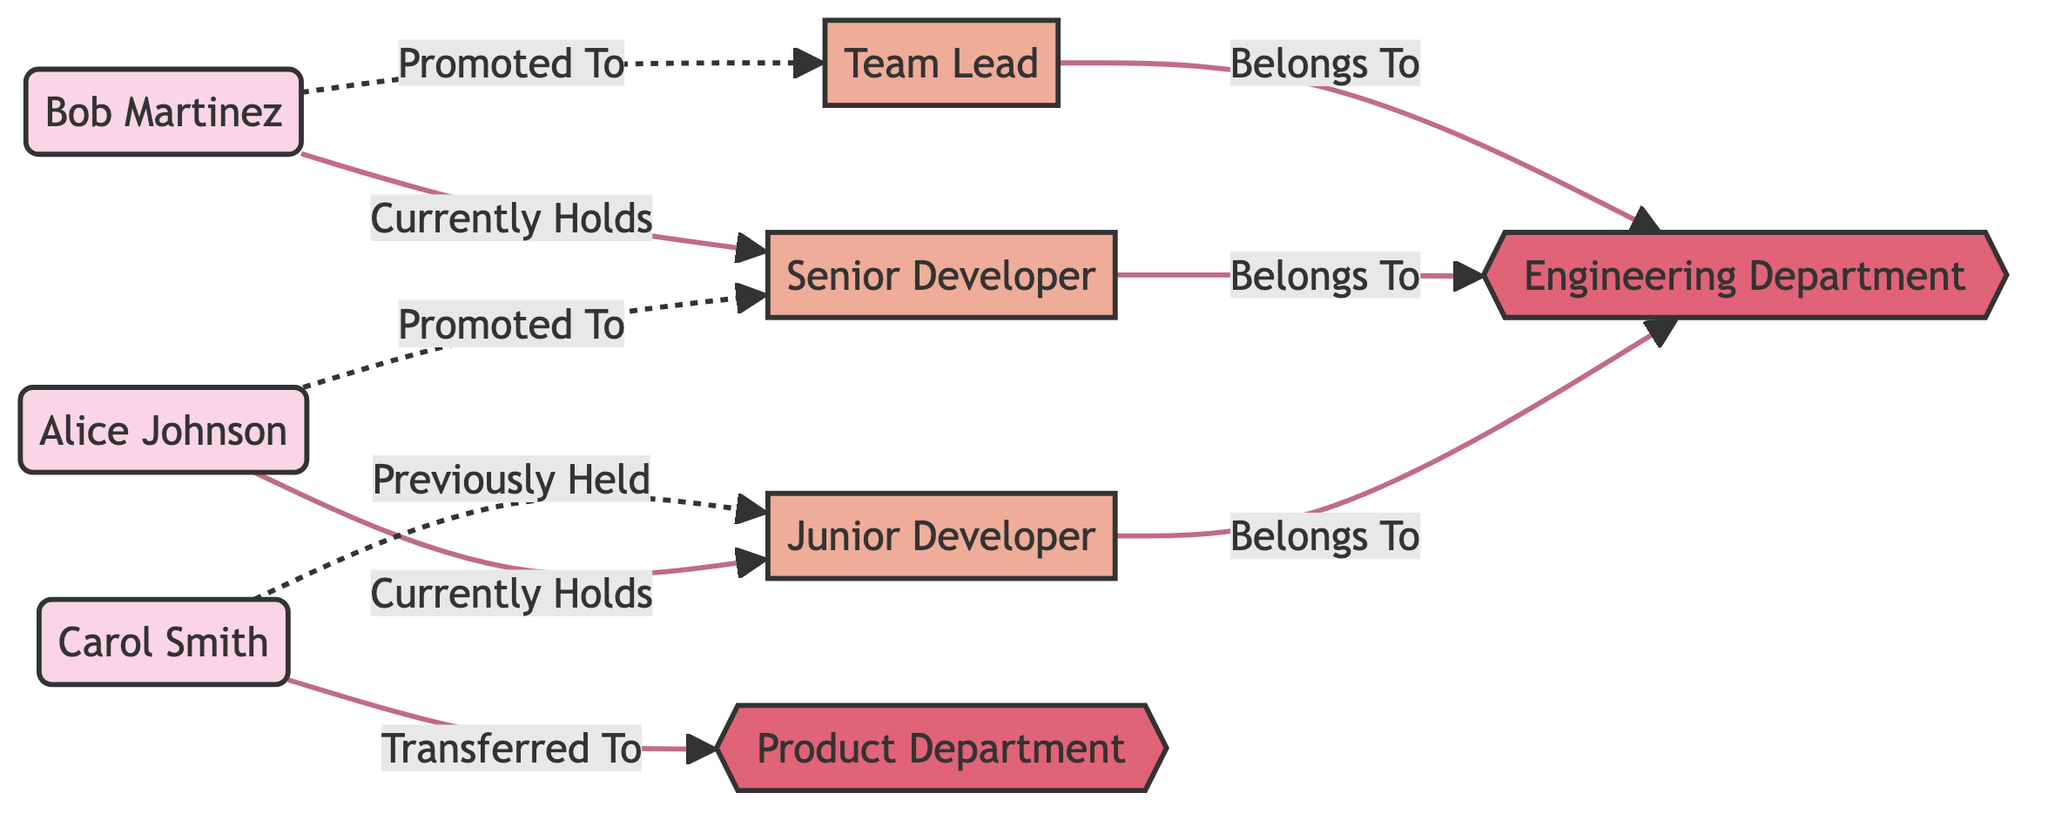What is the number of employees in the diagram? There are three employees listed: Alice Johnson, Bob Martinez, and Carol Smith. Therefore, counting these nodes provides the total number of employees.
Answer: 3 Which position does Alice Johnson currently hold? By examining the diagram, we can see that the edge connecting Alice Johnson to the Junior Developer position indicates she currently holds this position.
Answer: Junior Developer How many positions are depicted in the diagram? The diagram shows three positions: Junior Developer, Senior Developer, and Team Lead. By counting these positions, we get the total number of distinct roles.
Answer: 3 Who was previously held by Carol Smith? Carol Smith has a connection labeled "Previously Held" that leads to the Junior Developer position. This indicates that Carol Smith held this position before.
Answer: Junior Developer What department does the Senior Developer position belong to? The diagram shows an edge indicating that the Senior Developer position belongs to the Engineering Department. By following this connection, we find the answer.
Answer: Engineering Department How many promotions have Alice Johnson and Bob Martinez received in total? Alice Johnson has one promotion (to Senior Developer), and Bob Martinez has one promotion (to Team Lead). Adding these gives a total of two promotions.
Answer: 2 Who transferred to the Product Department? The edge connecting Carol Smith to the Product Department indicates that she transferred there. Therefore, she is the person in question.
Answer: Carol Smith What is the total number of edges in the diagram? By counting the connections (edges) presented in the diagram, there are seven edges total, linking the employees, positions, and departments.
Answer: 7 Which employee is promoted to Team Lead? The diagram indicates that Bob Martinez is the employee promoted to the Team Lead position following the edge labeled "Promoted To."
Answer: Bob Martinez 